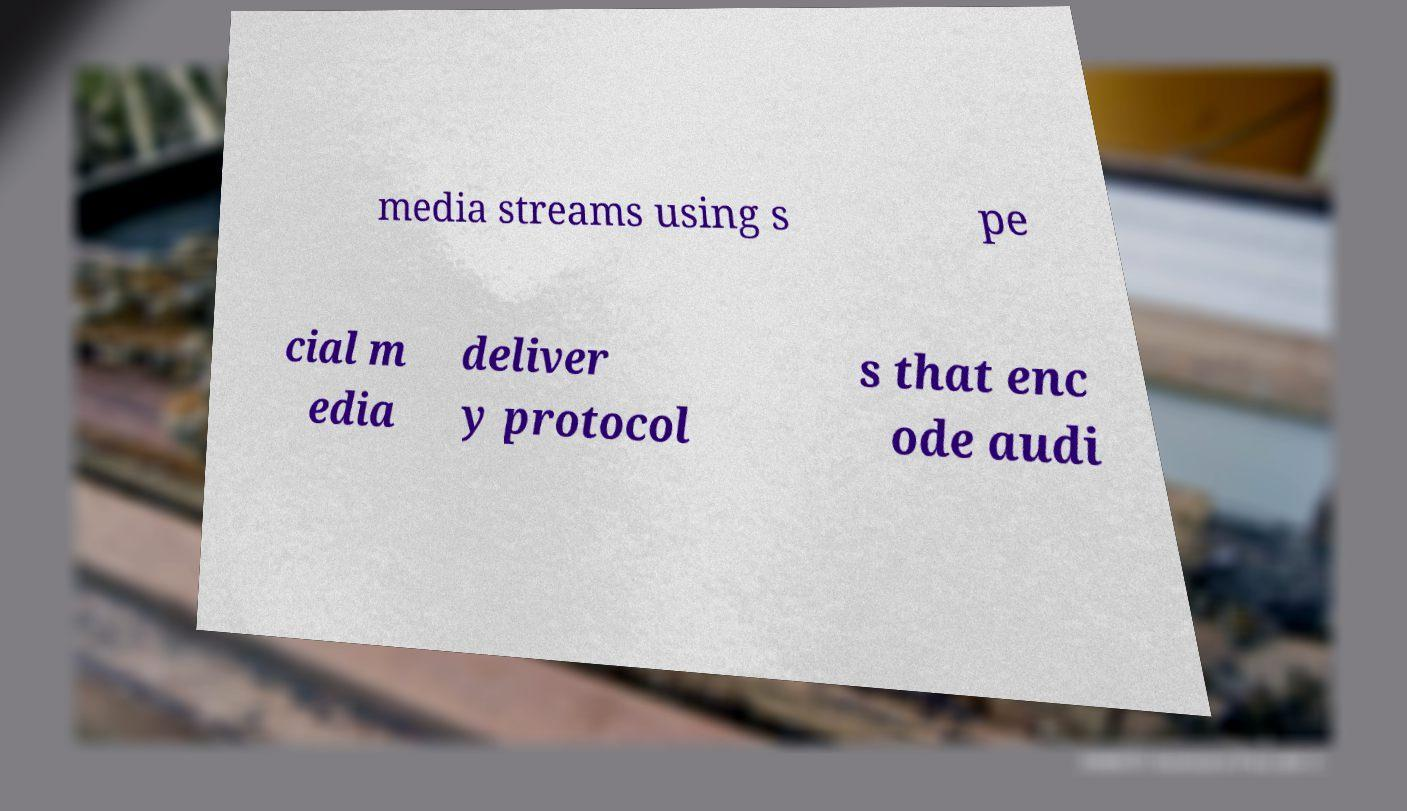For documentation purposes, I need the text within this image transcribed. Could you provide that? media streams using s pe cial m edia deliver y protocol s that enc ode audi 